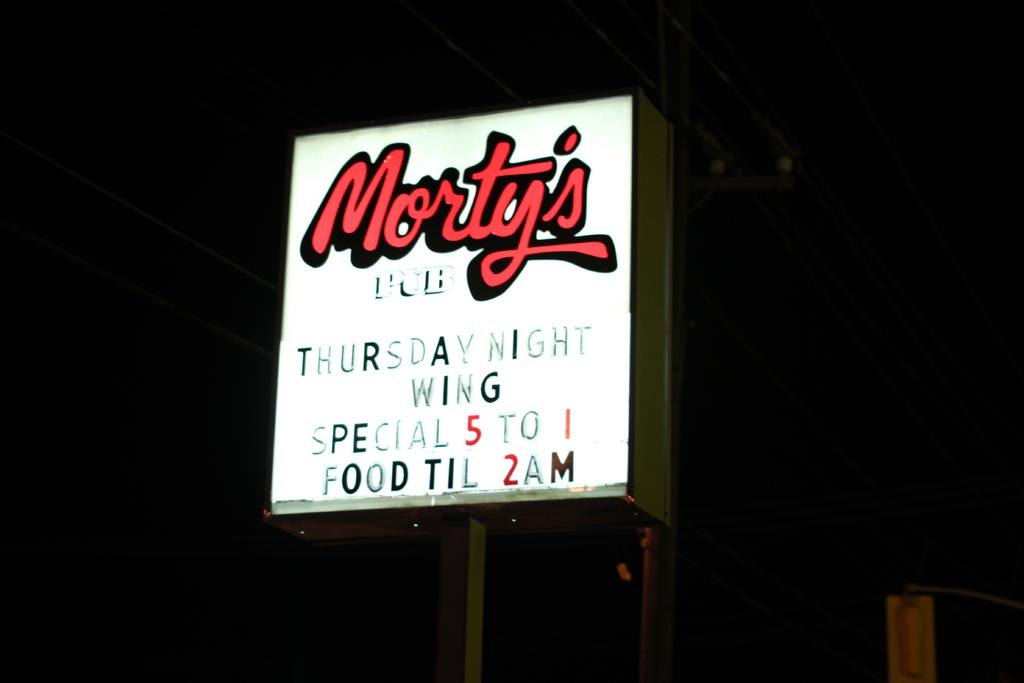<image>
Create a compact narrative representing the image presented. A sign that says Morty's Pub is glowing at night. 